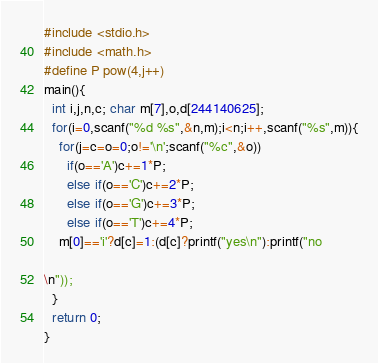<code> <loc_0><loc_0><loc_500><loc_500><_C_>#include <stdio.h>
#include <math.h>
#define P pow(4,j++)
main(){
  int i,j,n,c; char m[7],o,d[244140625];
  for(i=0,scanf("%d %s",&n,m);i<n;i++,scanf("%s",m)){
    for(j=c=o=0;o!='\n';scanf("%c",&o))
      if(o=='A')c+=1*P;
      else if(o=='C')c+=2*P;
      else if(o=='G')c+=3*P;
      else if(o=='T')c+=4*P;
    m[0]=='i'?d[c]=1:(d[c]?printf("yes\n"):printf("no

\n"));
  }
  return 0;
}</code> 